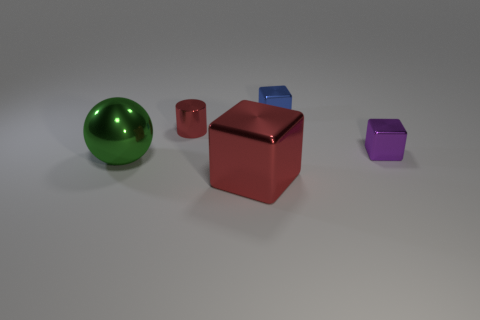Subtract all purple blocks. How many blocks are left? 2 Add 2 small purple metal things. How many objects exist? 7 Subtract all blue blocks. How many blocks are left? 2 Subtract all cylinders. How many objects are left? 4 Add 3 big red metallic things. How many big red metallic things exist? 4 Subtract 0 green cylinders. How many objects are left? 5 Subtract all yellow cylinders. Subtract all red spheres. How many cylinders are left? 1 Subtract all large green spheres. Subtract all tiny red shiny cylinders. How many objects are left? 3 Add 3 small red metallic cylinders. How many small red metallic cylinders are left? 4 